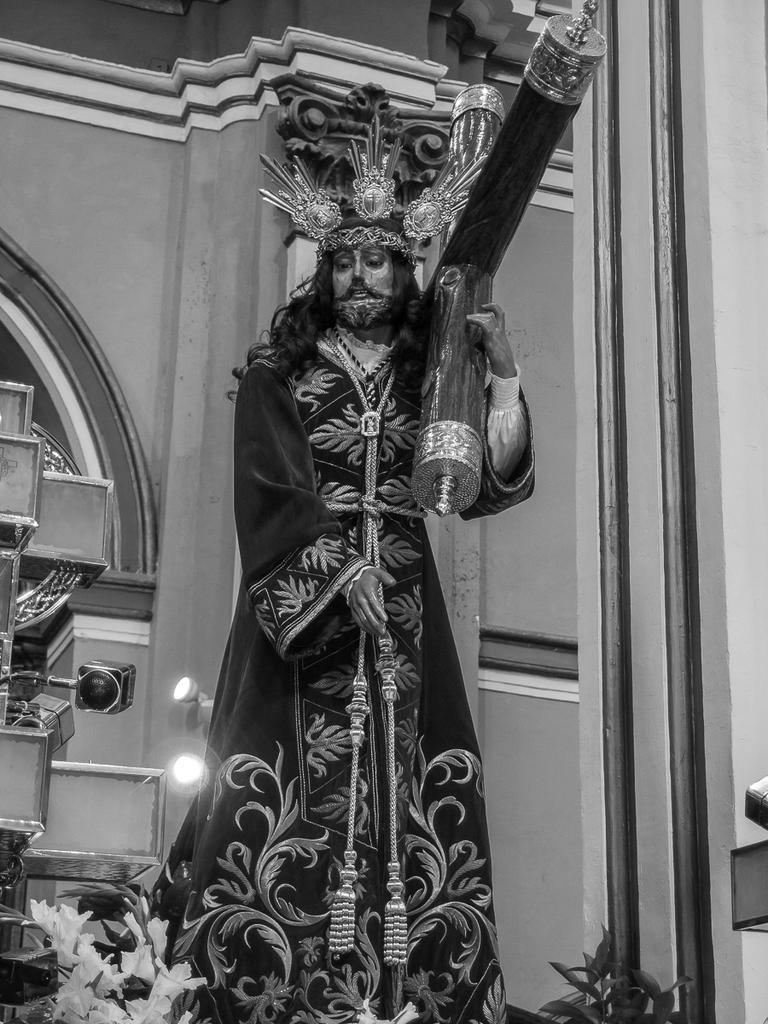What is the main subject in the image? There is a statue in the image. What other elements can be seen in the image besides the statue? There are plants and an electric light visible in the image. What type of structure is present in the image? There are walls in the image. What type of person is depicted in the statue in the image? There is no person depicted in the statue in the image; it is a statue of an object or figure. What belief system is represented by the statue in the image? There is no indication of a specific belief system represented by the statue in the image. 